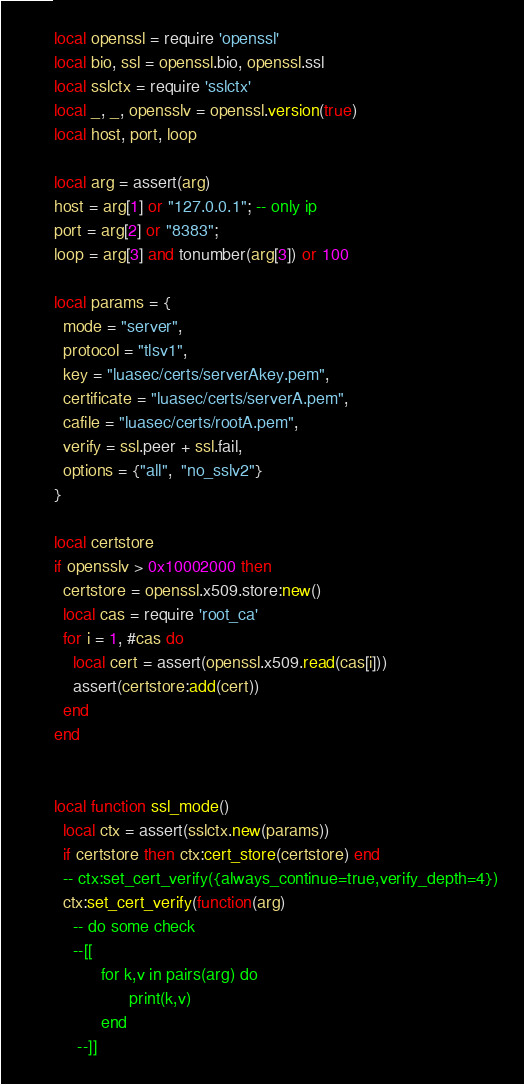Convert code to text. <code><loc_0><loc_0><loc_500><loc_500><_Lua_>local openssl = require 'openssl'
local bio, ssl = openssl.bio, openssl.ssl
local sslctx = require 'sslctx'
local _, _, opensslv = openssl.version(true)
local host, port, loop

local arg = assert(arg)
host = arg[1] or "127.0.0.1"; -- only ip
port = arg[2] or "8383";
loop = arg[3] and tonumber(arg[3]) or 100

local params = {
  mode = "server",
  protocol = "tlsv1",
  key = "luasec/certs/serverAkey.pem",
  certificate = "luasec/certs/serverA.pem",
  cafile = "luasec/certs/rootA.pem",
  verify = ssl.peer + ssl.fail,
  options = {"all",  "no_sslv2"}
}

local certstore
if opensslv > 0x10002000 then
  certstore = openssl.x509.store:new()
  local cas = require 'root_ca'
  for i = 1, #cas do
    local cert = assert(openssl.x509.read(cas[i]))
    assert(certstore:add(cert))
  end
end


local function ssl_mode()
  local ctx = assert(sslctx.new(params))
  if certstore then ctx:cert_store(certstore) end
  -- ctx:set_cert_verify({always_continue=true,verify_depth=4})
  ctx:set_cert_verify(function(arg)
    -- do some check
    --[[
          for k,v in pairs(arg) do
                print(k,v)
          end
     --]]</code> 